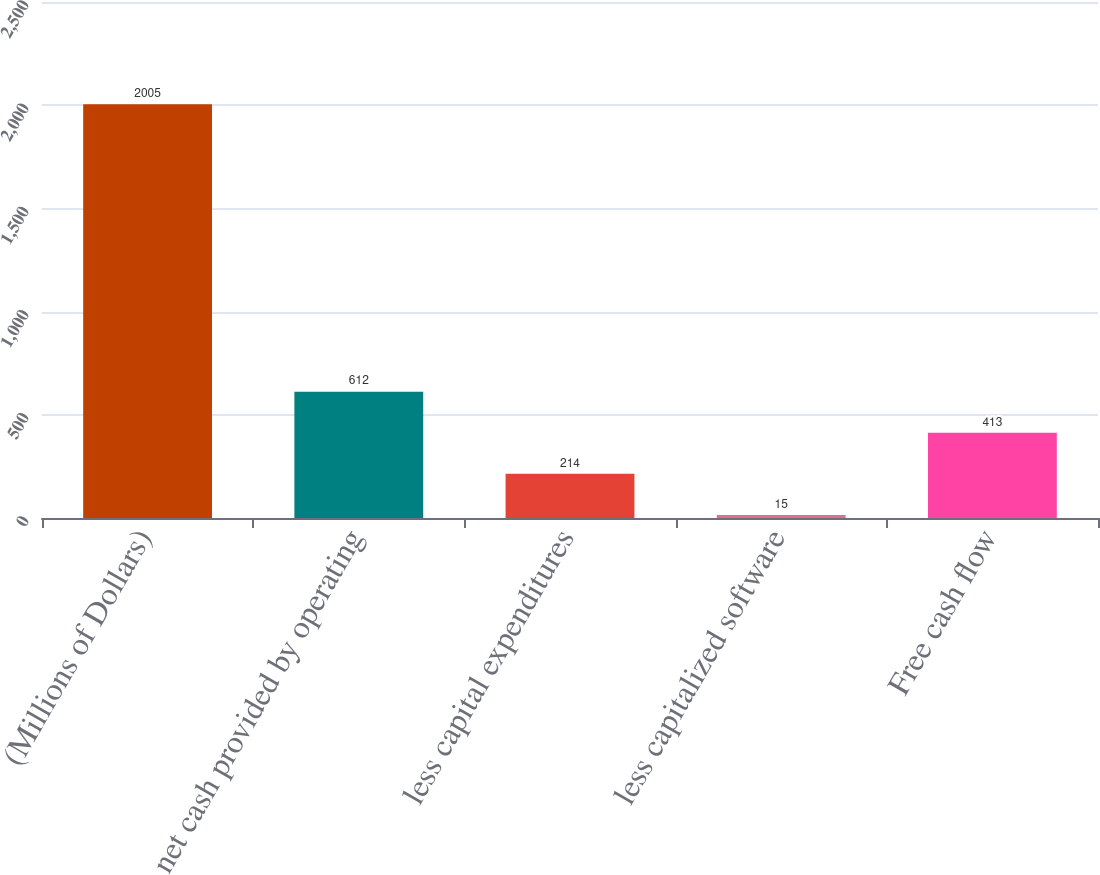Convert chart. <chart><loc_0><loc_0><loc_500><loc_500><bar_chart><fcel>(Millions of Dollars)<fcel>net cash provided by operating<fcel>less capital expenditures<fcel>less capitalized software<fcel>Free cash flow<nl><fcel>2005<fcel>612<fcel>214<fcel>15<fcel>413<nl></chart> 